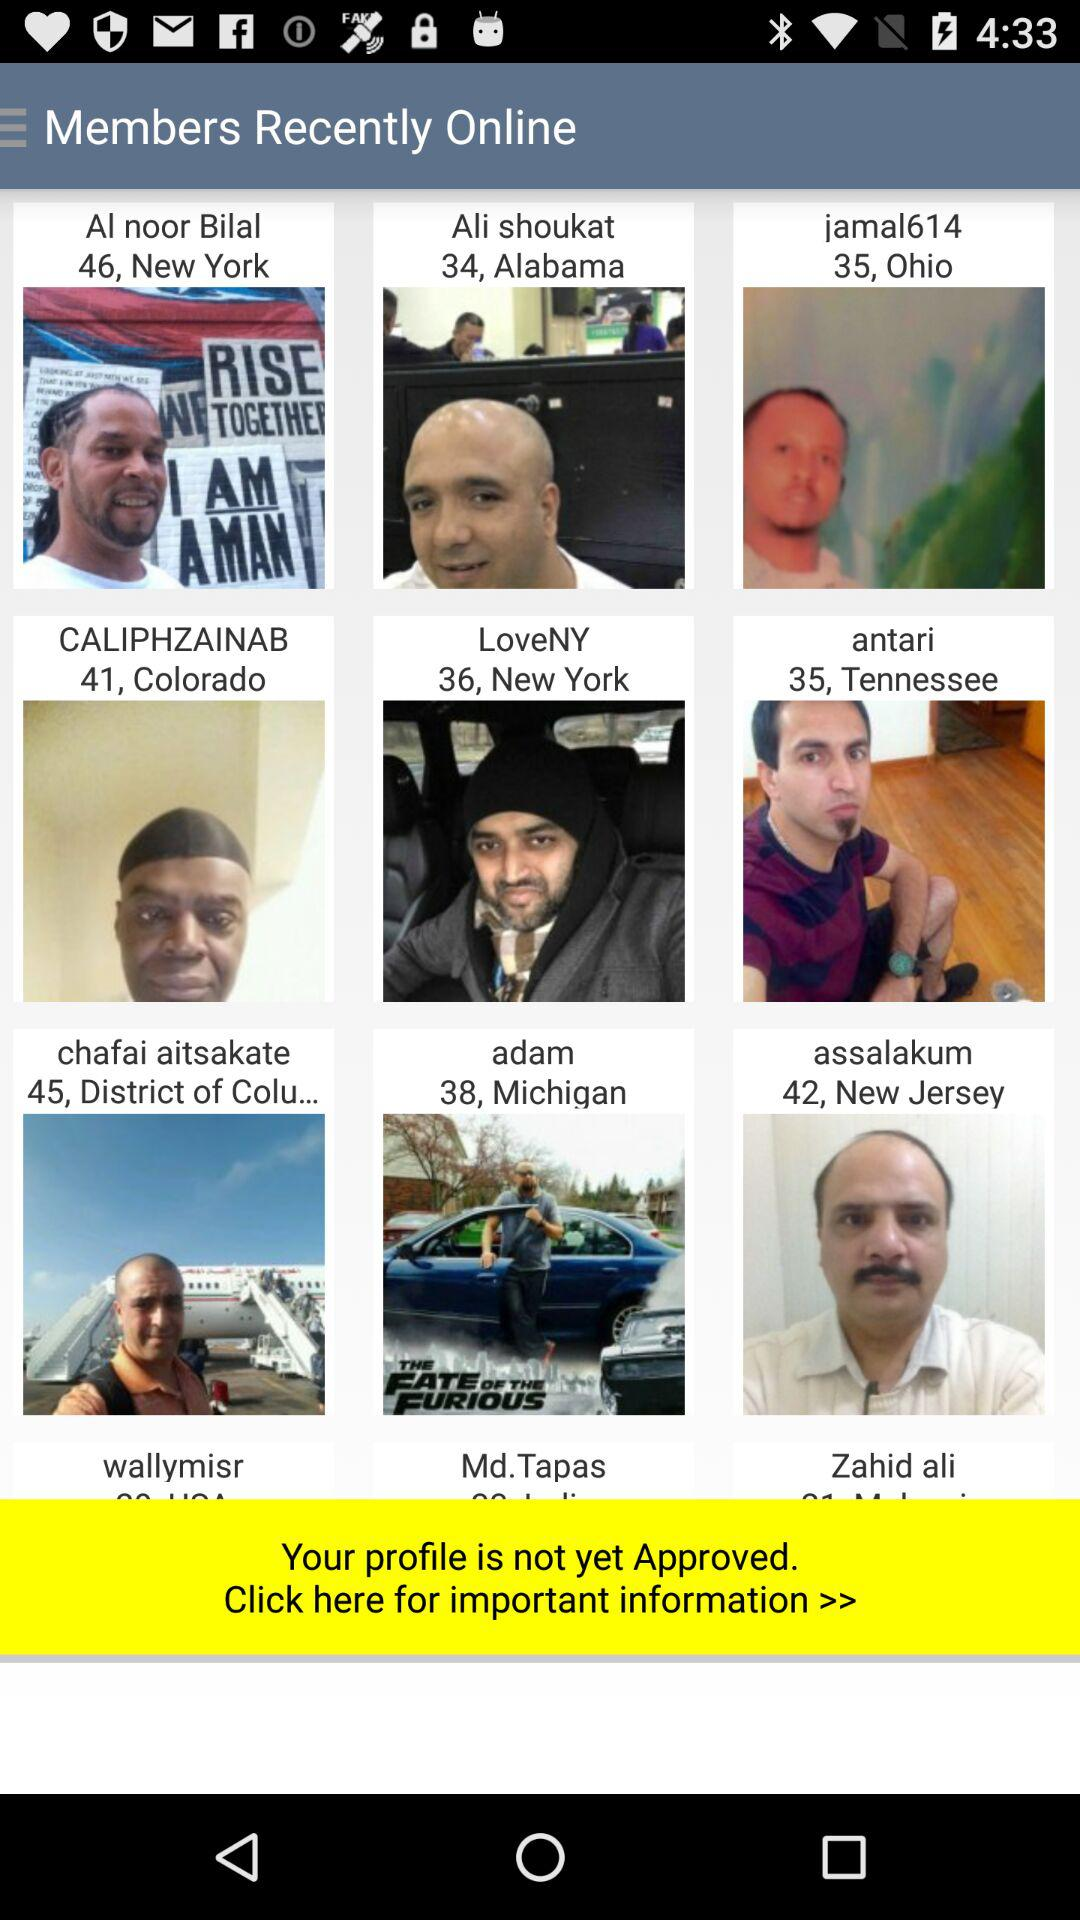What is the mentioned location of "LoveNY"? The mentioned location is New York. 